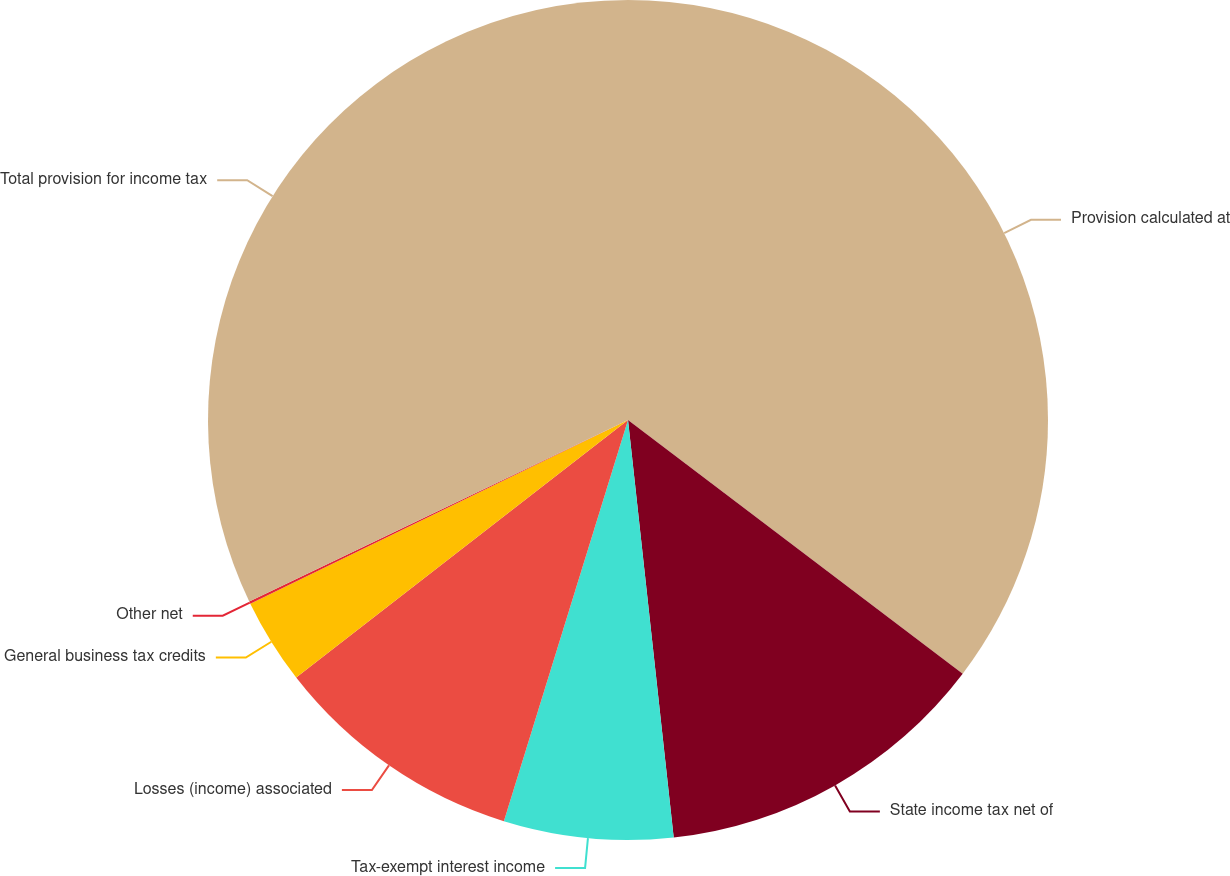<chart> <loc_0><loc_0><loc_500><loc_500><pie_chart><fcel>Provision calculated at<fcel>State income tax net of<fcel>Tax-exempt interest income<fcel>Losses (income) associated<fcel>General business tax credits<fcel>Other net<fcel>Total provision for income tax<nl><fcel>35.32%<fcel>12.94%<fcel>6.51%<fcel>9.72%<fcel>3.3%<fcel>0.09%<fcel>32.11%<nl></chart> 